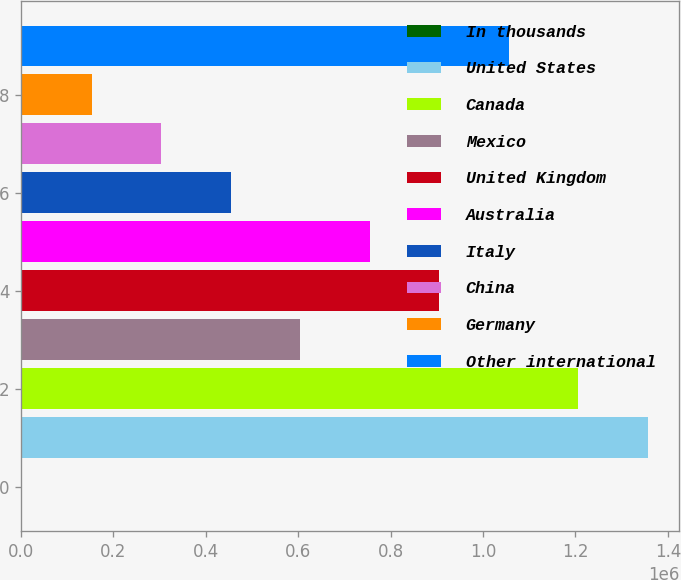Convert chart to OTSL. <chart><loc_0><loc_0><loc_500><loc_500><bar_chart><fcel>In thousands<fcel>United States<fcel>Canada<fcel>Mexico<fcel>United Kingdom<fcel>Australia<fcel>Italy<fcel>China<fcel>Germany<fcel>Other international<nl><fcel>2010<fcel>1.35651e+06<fcel>1.20601e+06<fcel>604011<fcel>905011<fcel>754511<fcel>453511<fcel>303010<fcel>152510<fcel>1.05551e+06<nl></chart> 